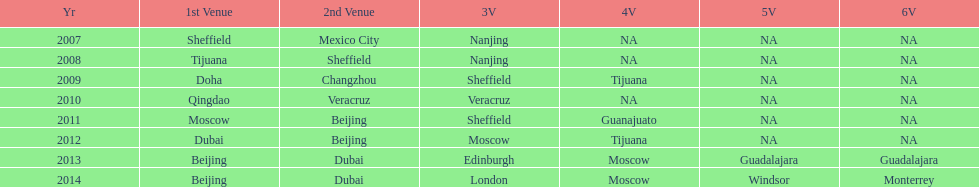In what year was the 3rd venue the same as 2011's 1st venue? 2012. 